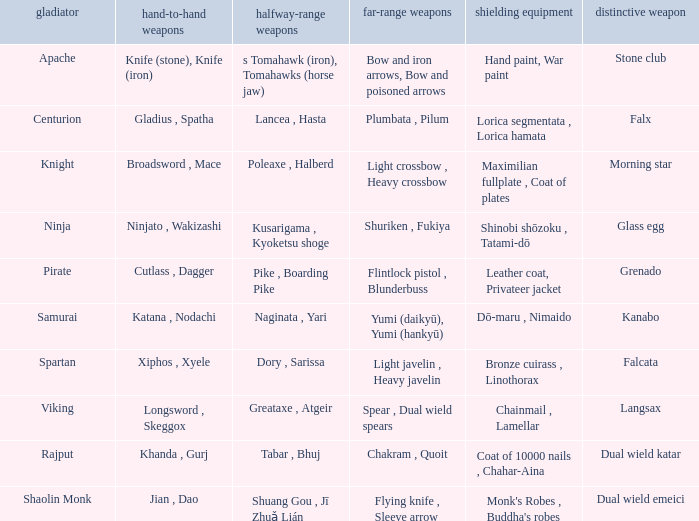If the Close ranged weapons are the knife (stone), knife (iron), what are the Long ranged weapons? Bow and iron arrows, Bow and poisoned arrows. 